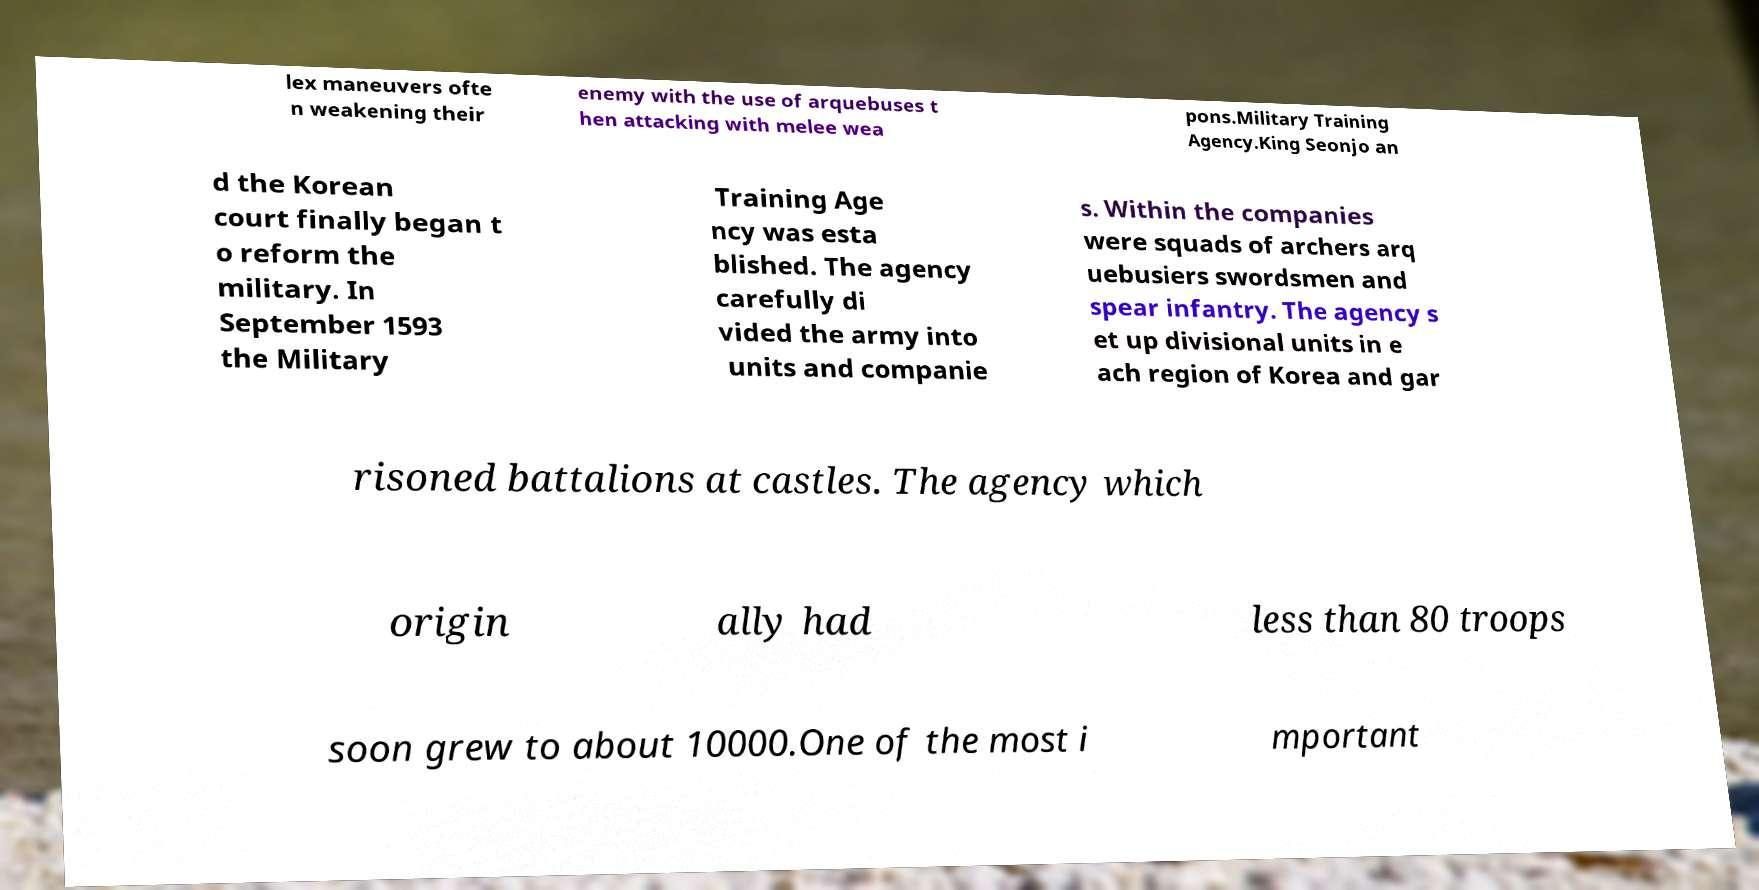Could you extract and type out the text from this image? lex maneuvers ofte n weakening their enemy with the use of arquebuses t hen attacking with melee wea pons.Military Training Agency.King Seonjo an d the Korean court finally began t o reform the military. In September 1593 the Military Training Age ncy was esta blished. The agency carefully di vided the army into units and companie s. Within the companies were squads of archers arq uebusiers swordsmen and spear infantry. The agency s et up divisional units in e ach region of Korea and gar risoned battalions at castles. The agency which origin ally had less than 80 troops soon grew to about 10000.One of the most i mportant 